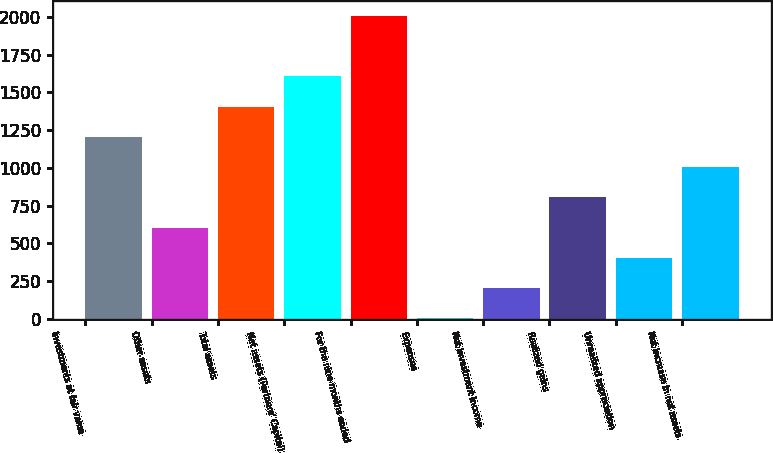<chart> <loc_0><loc_0><loc_500><loc_500><bar_chart><fcel>Investments at fair value<fcel>Other assets<fcel>Total assets<fcel>Net assets (Partners' Capital)<fcel>For the nine months ended<fcel>Expenses<fcel>Net investment income<fcel>Realized gains<fcel>Unrealized appreciation<fcel>Net increase in net assets<nl><fcel>1204.8<fcel>603.9<fcel>1405.1<fcel>1605.4<fcel>2006<fcel>3<fcel>203.3<fcel>804.2<fcel>403.6<fcel>1004.5<nl></chart> 